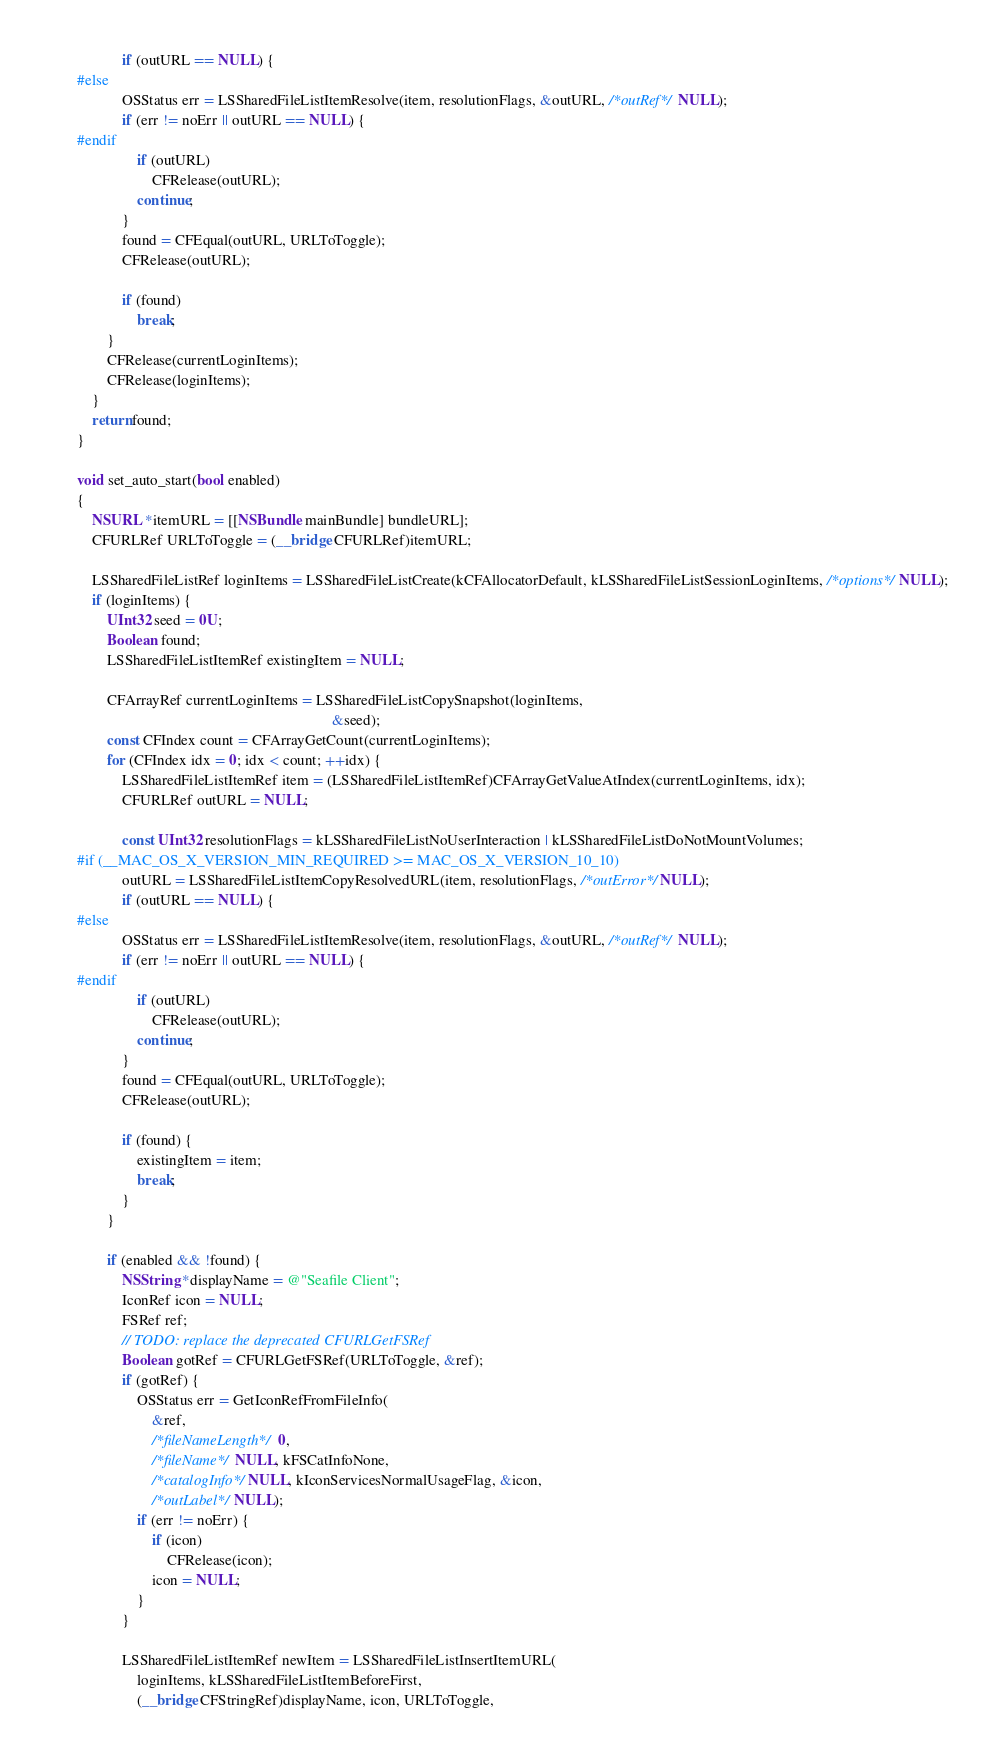Convert code to text. <code><loc_0><loc_0><loc_500><loc_500><_ObjectiveC_>            if (outURL == NULL) {
#else
            OSStatus err = LSSharedFileListItemResolve(item, resolutionFlags, &outURL, /*outRef*/ NULL);
            if (err != noErr || outURL == NULL) {
#endif
                if (outURL)
                    CFRelease(outURL);
                continue;
            }
            found = CFEqual(outURL, URLToToggle);
            CFRelease(outURL);

            if (found)
                break;
        }
        CFRelease(currentLoginItems);
        CFRelease(loginItems);
    }
    return found;
}

void set_auto_start(bool enabled)
{
    NSURL *itemURL = [[NSBundle mainBundle] bundleURL];
    CFURLRef URLToToggle = (__bridge CFURLRef)itemURL;

    LSSharedFileListRef loginItems = LSSharedFileListCreate(kCFAllocatorDefault, kLSSharedFileListSessionLoginItems, /*options*/ NULL);
    if (loginItems) {
        UInt32 seed = 0U;
        Boolean found;
        LSSharedFileListItemRef existingItem = NULL;

        CFArrayRef currentLoginItems = LSSharedFileListCopySnapshot(loginItems,
                                                                    &seed);
        const CFIndex count = CFArrayGetCount(currentLoginItems);
        for (CFIndex idx = 0; idx < count; ++idx) {
            LSSharedFileListItemRef item = (LSSharedFileListItemRef)CFArrayGetValueAtIndex(currentLoginItems, idx);
            CFURLRef outURL = NULL;

            const UInt32 resolutionFlags = kLSSharedFileListNoUserInteraction | kLSSharedFileListDoNotMountVolumes;
#if (__MAC_OS_X_VERSION_MIN_REQUIRED >= MAC_OS_X_VERSION_10_10)
            outURL = LSSharedFileListItemCopyResolvedURL(item, resolutionFlags, /*outError*/ NULL);
            if (outURL == NULL) {
#else
            OSStatus err = LSSharedFileListItemResolve(item, resolutionFlags, &outURL, /*outRef*/ NULL);
            if (err != noErr || outURL == NULL) {
#endif
                if (outURL)
                    CFRelease(outURL);
                continue;
            }
            found = CFEqual(outURL, URLToToggle);
            CFRelease(outURL);

            if (found) {
                existingItem = item;
                break;
            }
        }

        if (enabled && !found) {
            NSString *displayName = @"Seafile Client";
            IconRef icon = NULL;
            FSRef ref;
            // TODO: replace the deprecated CFURLGetFSRef
            Boolean gotRef = CFURLGetFSRef(URLToToggle, &ref);
            if (gotRef) {
                OSStatus err = GetIconRefFromFileInfo(
                    &ref,
                    /*fileNameLength*/ 0,
                    /*fileName*/ NULL, kFSCatInfoNone,
                    /*catalogInfo*/ NULL, kIconServicesNormalUsageFlag, &icon,
                    /*outLabel*/ NULL);
                if (err != noErr) {
                    if (icon)
                        CFRelease(icon);
                    icon = NULL;
                }
            }

            LSSharedFileListItemRef newItem = LSSharedFileListInsertItemURL(
                loginItems, kLSSharedFileListItemBeforeFirst,
                (__bridge CFStringRef)displayName, icon, URLToToggle,</code> 